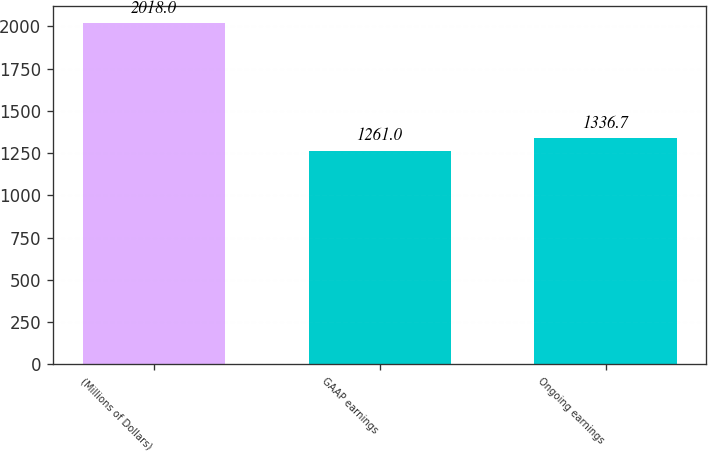Convert chart. <chart><loc_0><loc_0><loc_500><loc_500><bar_chart><fcel>(Millions of Dollars)<fcel>GAAP earnings<fcel>Ongoing earnings<nl><fcel>2018<fcel>1261<fcel>1336.7<nl></chart> 